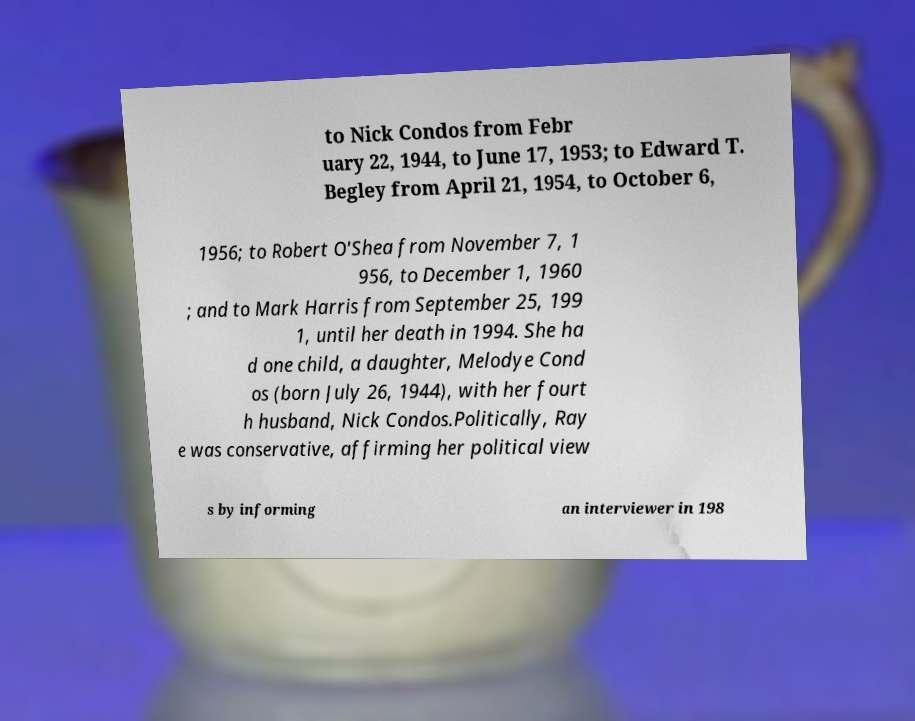Could you extract and type out the text from this image? to Nick Condos from Febr uary 22, 1944, to June 17, 1953; to Edward T. Begley from April 21, 1954, to October 6, 1956; to Robert O'Shea from November 7, 1 956, to December 1, 1960 ; and to Mark Harris from September 25, 199 1, until her death in 1994. She ha d one child, a daughter, Melodye Cond os (born July 26, 1944), with her fourt h husband, Nick Condos.Politically, Ray e was conservative, affirming her political view s by informing an interviewer in 198 